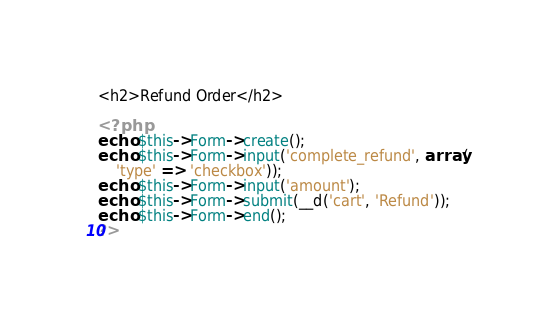<code> <loc_0><loc_0><loc_500><loc_500><_PHP_><h2>Refund Order</h2>

<?php
echo $this->Form->create();
echo $this->Form->input('complete_refund', array(
    'type' => 'checkbox'));
echo $this->Form->input('amount');
echo $this->Form->submit(__d('cart', 'Refund'));
echo $this->Form->end();
?>
</code> 